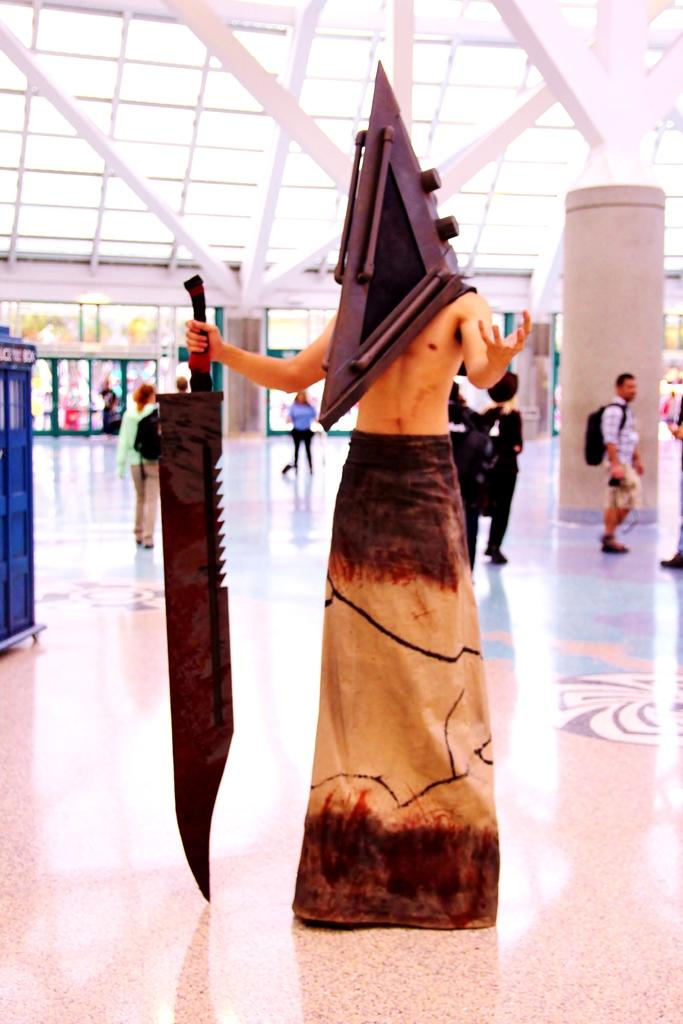What is the person in the image wearing? The person is wearing a costume in the image. What is the person holding in the image? The person is holding a weapon in the image. What can be seen at the bottom of the image? The floor is visible at the bottom of the image. What is visible in the background of the image? There are people, at least one pillar, and other objects present in the background of the image. What type of cable can be seen connecting the egg to the visitor in the image? There is no cable, egg, or visitor present in the image. 